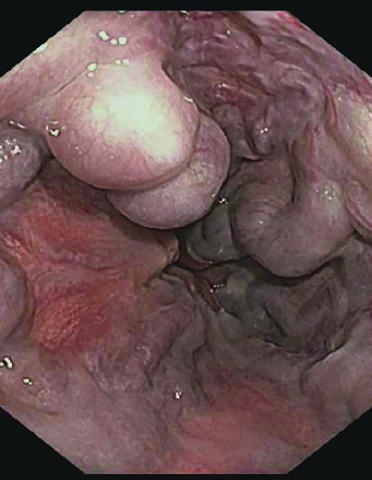s endoscopy more commonly used to identify varices?
Answer the question using a single word or phrase. Yes 